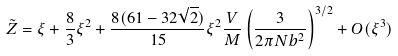<formula> <loc_0><loc_0><loc_500><loc_500>\tilde { Z } = \xi + \frac { 8 } { 3 } \xi ^ { 2 } + \frac { 8 ( 6 1 - 3 2 \sqrt { 2 } ) } { 1 5 } \xi ^ { 2 } \frac { V } { M } \left ( \frac { 3 } { 2 \pi N b ^ { 2 } } \right ) ^ { 3 / 2 } + O ( \xi ^ { 3 } )</formula> 